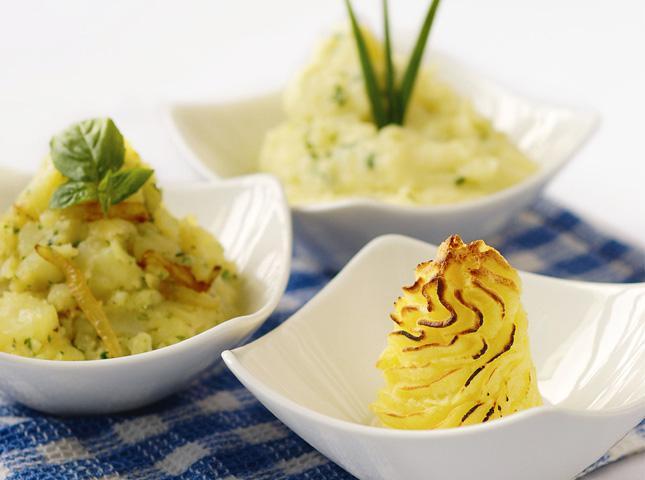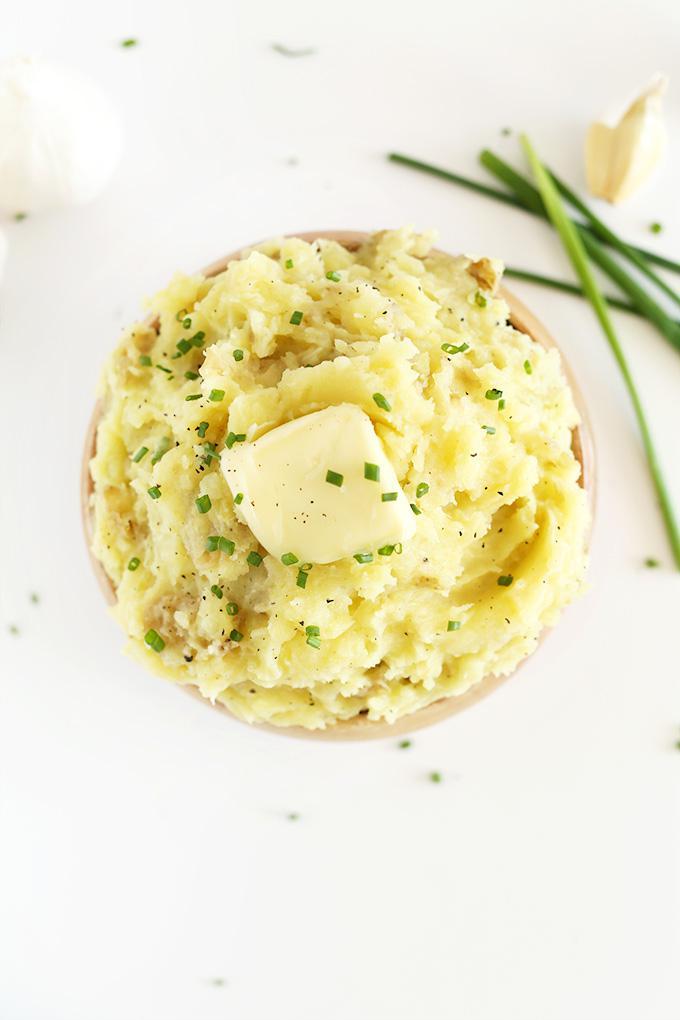The first image is the image on the left, the second image is the image on the right. Analyze the images presented: Is the assertion "All images include an item of silverware by a prepared potato dish." valid? Answer yes or no. No. The first image is the image on the left, the second image is the image on the right. Given the left and right images, does the statement "There are three bowls in the left image." hold true? Answer yes or no. Yes. 